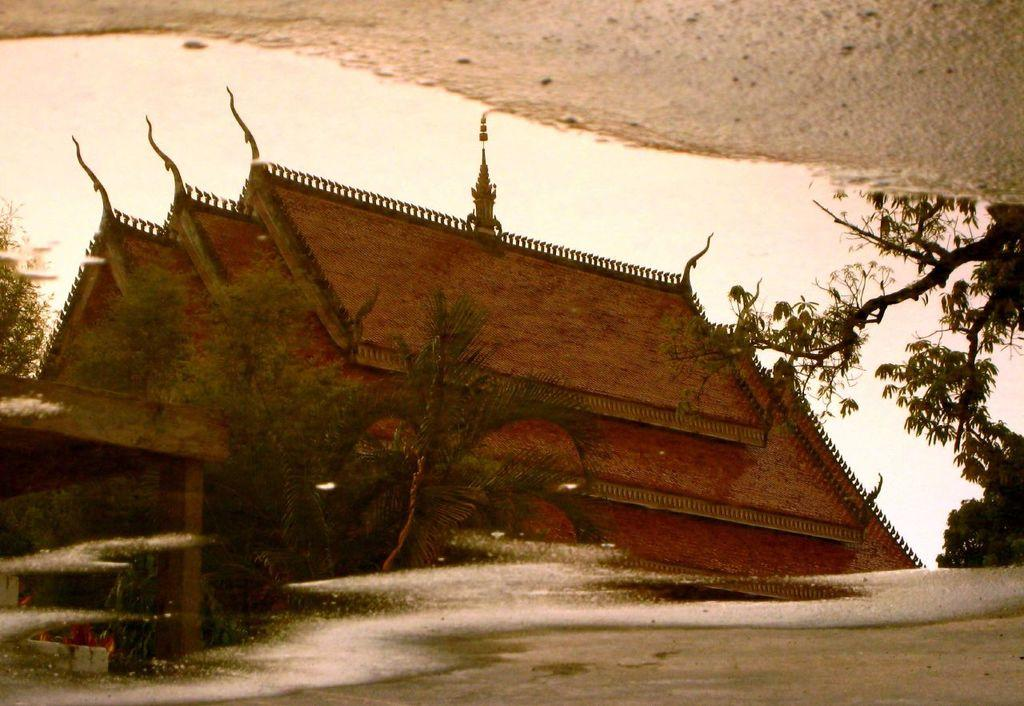What is the primary setting of the image? The primary setting of the image is a water surface. What structure can be seen on the water surface? There is a house on the water surface in the image. What is being reflected on the water surface? Trees are reflecting on the water surface. What type of land is visible in the background of the image? There is sand land visible in the background of the image. What type of brass instrument is being played on the water surface in the image? There is no brass instrument or any musical activity depicted in the image. 